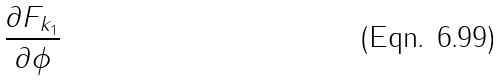<formula> <loc_0><loc_0><loc_500><loc_500>\frac { \partial F _ { k _ { 1 } } } { \partial \phi }</formula> 